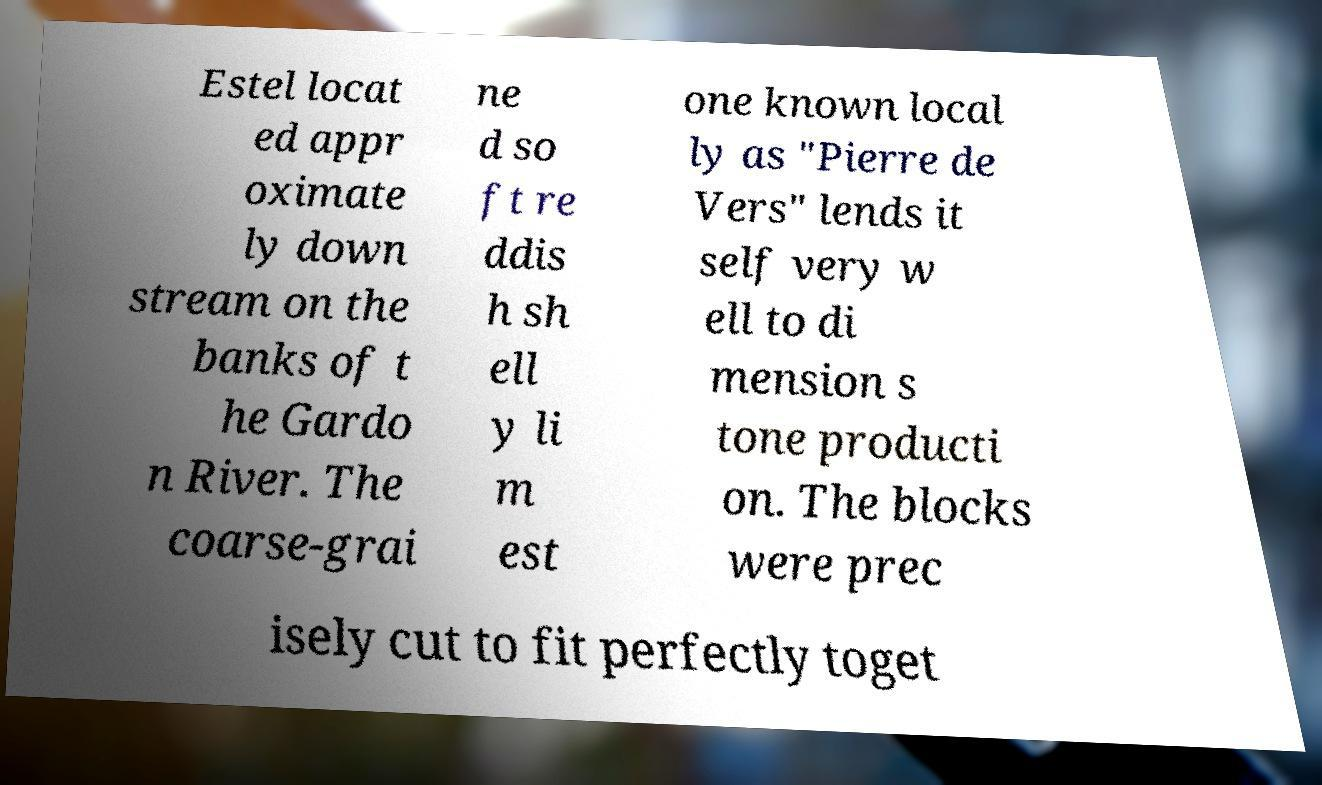Please identify and transcribe the text found in this image. Estel locat ed appr oximate ly down stream on the banks of t he Gardo n River. The coarse-grai ne d so ft re ddis h sh ell y li m est one known local ly as "Pierre de Vers" lends it self very w ell to di mension s tone producti on. The blocks were prec isely cut to fit perfectly toget 